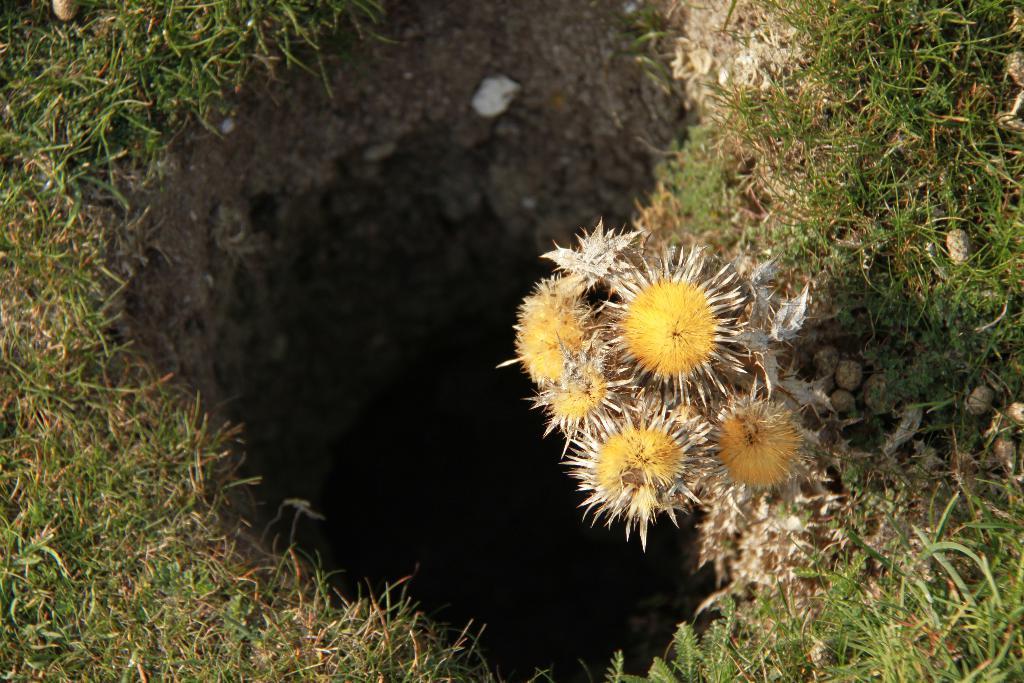Please provide a concise description of this image. In this image we can see some flowers, stones, grass and a burrow. 